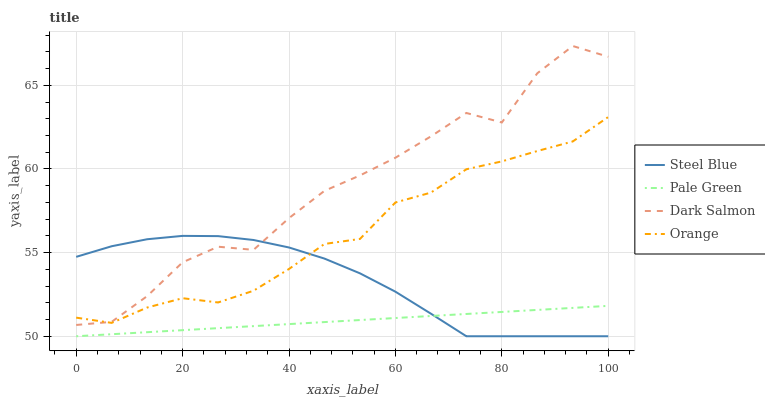Does Pale Green have the minimum area under the curve?
Answer yes or no. Yes. Does Dark Salmon have the maximum area under the curve?
Answer yes or no. Yes. Does Steel Blue have the minimum area under the curve?
Answer yes or no. No. Does Steel Blue have the maximum area under the curve?
Answer yes or no. No. Is Pale Green the smoothest?
Answer yes or no. Yes. Is Dark Salmon the roughest?
Answer yes or no. Yes. Is Steel Blue the smoothest?
Answer yes or no. No. Is Steel Blue the roughest?
Answer yes or no. No. Does Pale Green have the lowest value?
Answer yes or no. Yes. Does Dark Salmon have the lowest value?
Answer yes or no. No. Does Dark Salmon have the highest value?
Answer yes or no. Yes. Does Steel Blue have the highest value?
Answer yes or no. No. Is Pale Green less than Dark Salmon?
Answer yes or no. Yes. Is Orange greater than Pale Green?
Answer yes or no. Yes. Does Steel Blue intersect Dark Salmon?
Answer yes or no. Yes. Is Steel Blue less than Dark Salmon?
Answer yes or no. No. Is Steel Blue greater than Dark Salmon?
Answer yes or no. No. Does Pale Green intersect Dark Salmon?
Answer yes or no. No. 